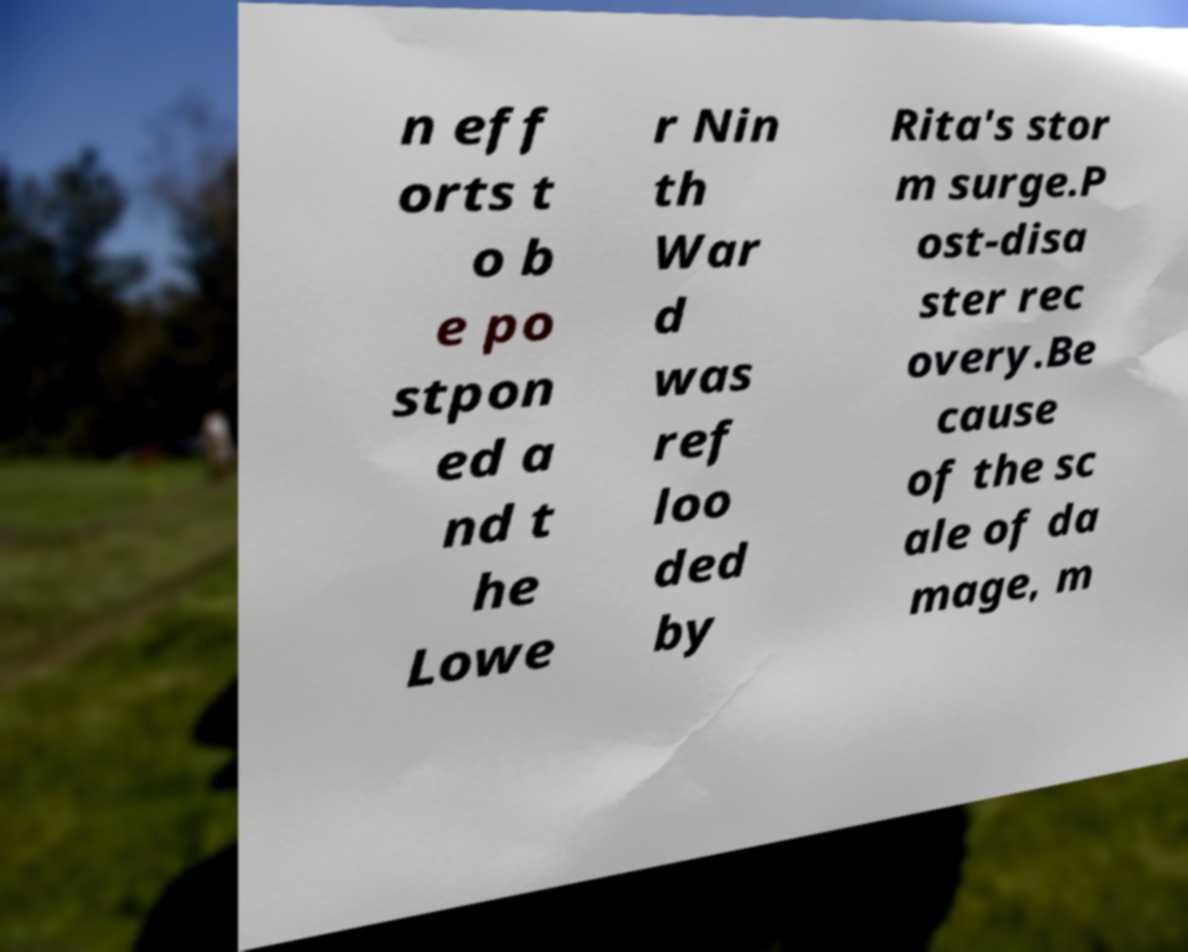Can you read and provide the text displayed in the image?This photo seems to have some interesting text. Can you extract and type it out for me? n eff orts t o b e po stpon ed a nd t he Lowe r Nin th War d was ref loo ded by Rita's stor m surge.P ost-disa ster rec overy.Be cause of the sc ale of da mage, m 